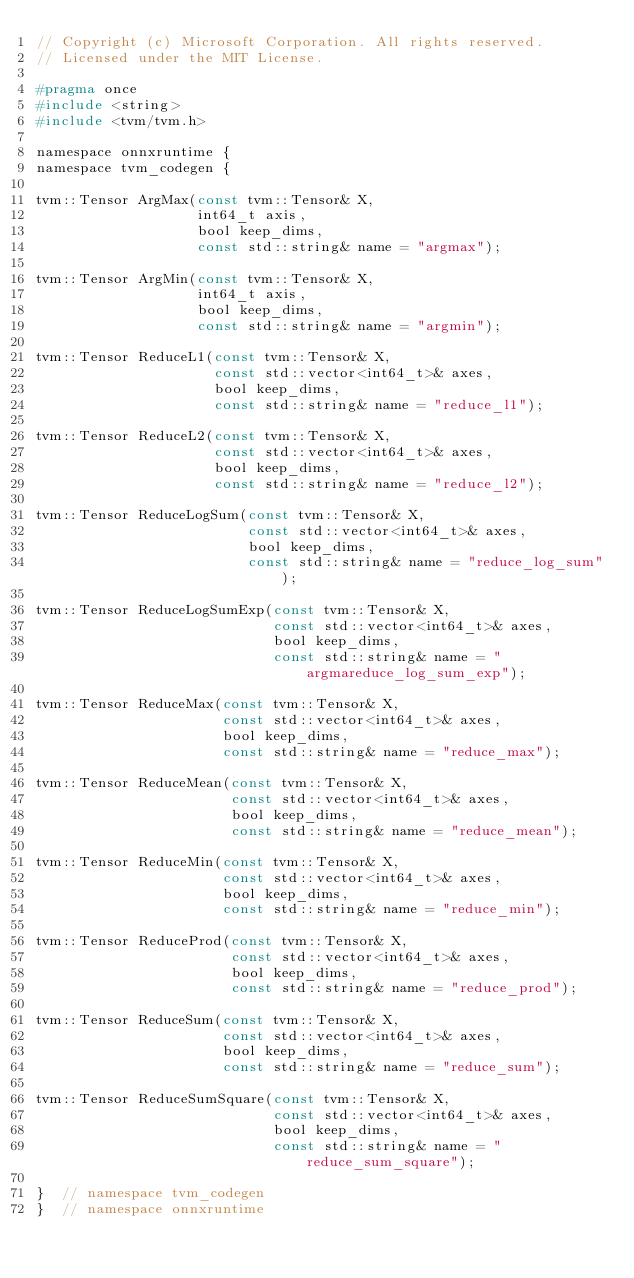<code> <loc_0><loc_0><loc_500><loc_500><_C_>// Copyright (c) Microsoft Corporation. All rights reserved.
// Licensed under the MIT License.

#pragma once
#include <string>
#include <tvm/tvm.h>

namespace onnxruntime {
namespace tvm_codegen {

tvm::Tensor ArgMax(const tvm::Tensor& X,
                   int64_t axis,
                   bool keep_dims,
                   const std::string& name = "argmax");

tvm::Tensor ArgMin(const tvm::Tensor& X,
                   int64_t axis,
                   bool keep_dims,
                   const std::string& name = "argmin");

tvm::Tensor ReduceL1(const tvm::Tensor& X,
                     const std::vector<int64_t>& axes,
                     bool keep_dims,
                     const std::string& name = "reduce_l1");

tvm::Tensor ReduceL2(const tvm::Tensor& X,
                     const std::vector<int64_t>& axes,
                     bool keep_dims,
                     const std::string& name = "reduce_l2");

tvm::Tensor ReduceLogSum(const tvm::Tensor& X,
                         const std::vector<int64_t>& axes,
                         bool keep_dims,
                         const std::string& name = "reduce_log_sum");

tvm::Tensor ReduceLogSumExp(const tvm::Tensor& X,
                            const std::vector<int64_t>& axes,
                            bool keep_dims,
                            const std::string& name = "argmareduce_log_sum_exp");

tvm::Tensor ReduceMax(const tvm::Tensor& X,
                      const std::vector<int64_t>& axes,
                      bool keep_dims,
                      const std::string& name = "reduce_max");

tvm::Tensor ReduceMean(const tvm::Tensor& X,
                       const std::vector<int64_t>& axes,
                       bool keep_dims,
                       const std::string& name = "reduce_mean");

tvm::Tensor ReduceMin(const tvm::Tensor& X,
                      const std::vector<int64_t>& axes,
                      bool keep_dims,
                      const std::string& name = "reduce_min");

tvm::Tensor ReduceProd(const tvm::Tensor& X,
                       const std::vector<int64_t>& axes,
                       bool keep_dims,
                       const std::string& name = "reduce_prod");

tvm::Tensor ReduceSum(const tvm::Tensor& X,
                      const std::vector<int64_t>& axes,
                      bool keep_dims,
                      const std::string& name = "reduce_sum");

tvm::Tensor ReduceSumSquare(const tvm::Tensor& X,
                            const std::vector<int64_t>& axes,
                            bool keep_dims,
                            const std::string& name = "reduce_sum_square");

}  // namespace tvm_codegen
}  // namespace onnxruntime
</code> 